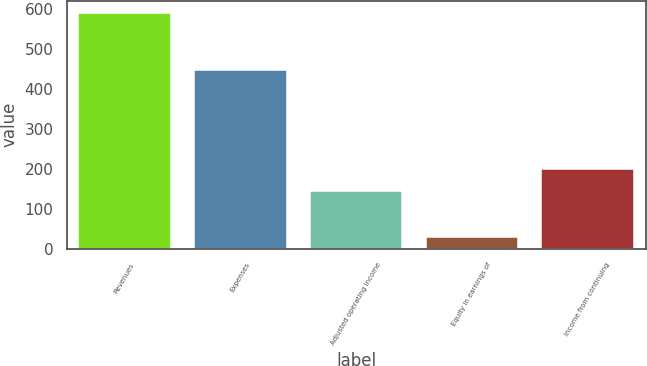Convert chart to OTSL. <chart><loc_0><loc_0><loc_500><loc_500><bar_chart><fcel>Revenues<fcel>Expenses<fcel>Adjusted operating income<fcel>Equity in earnings of<fcel>Income from continuing<nl><fcel>590<fcel>447<fcel>143<fcel>28<fcel>199.2<nl></chart> 